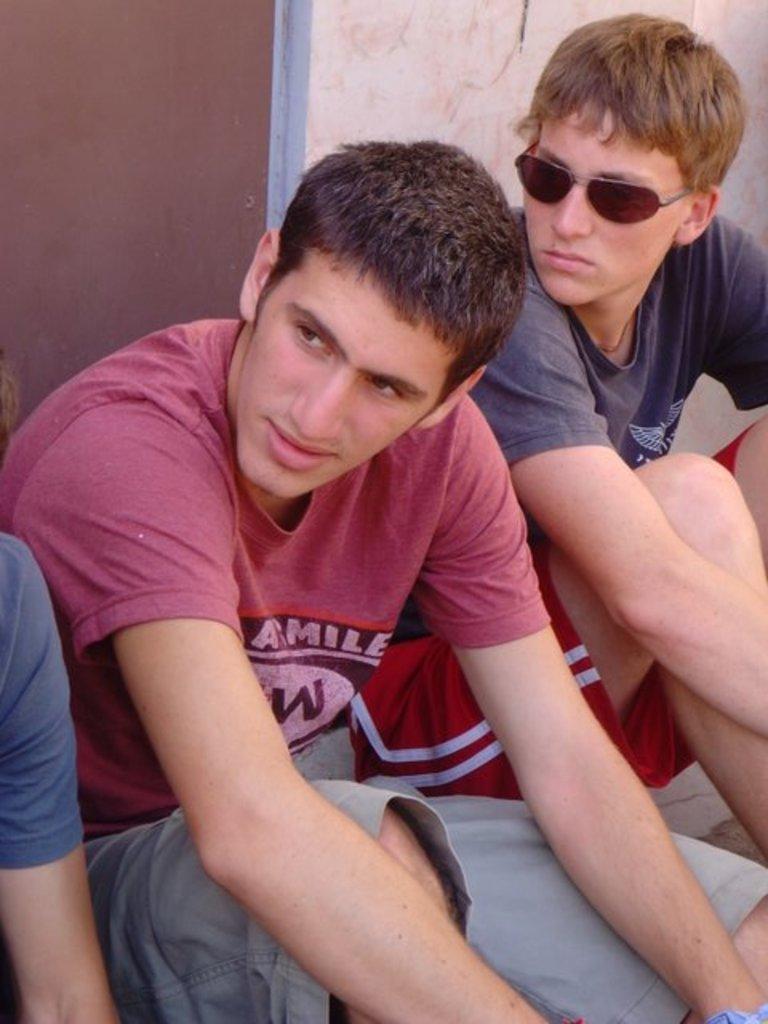Describe this image in one or two sentences. In this picture there are three people sitting on staircase, behind them there is a wall and a wooden door. 